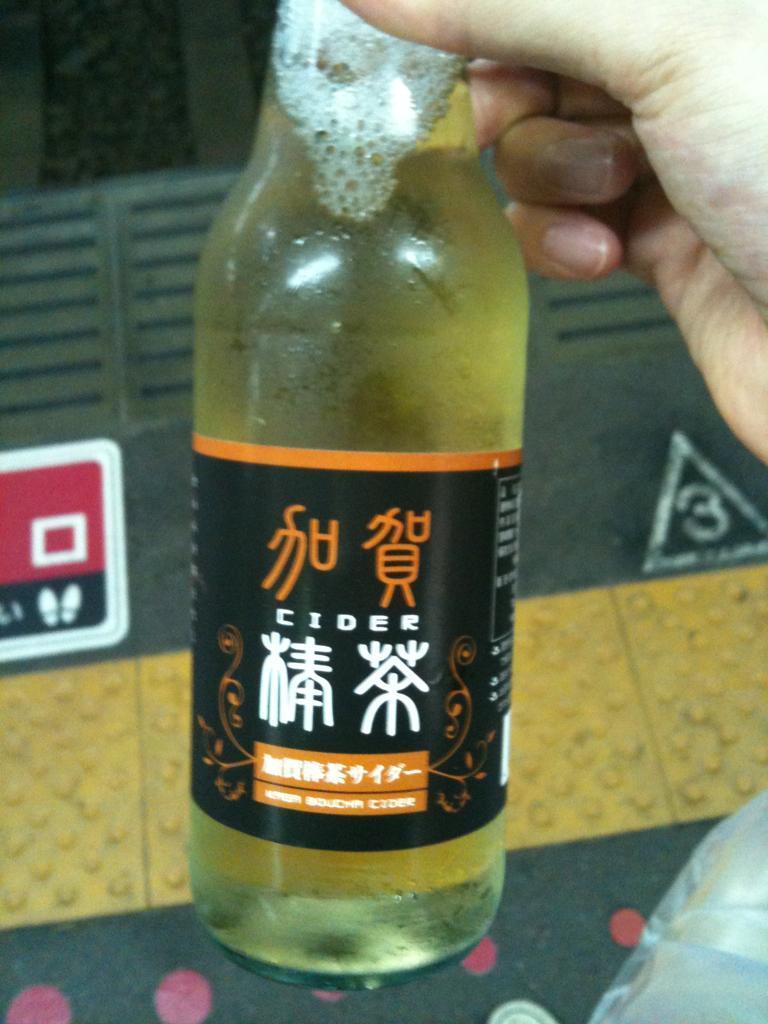What type of beverage is in the bottle?
Your answer should be very brief. Cider. What is the number in the background?
Offer a terse response. 3. 